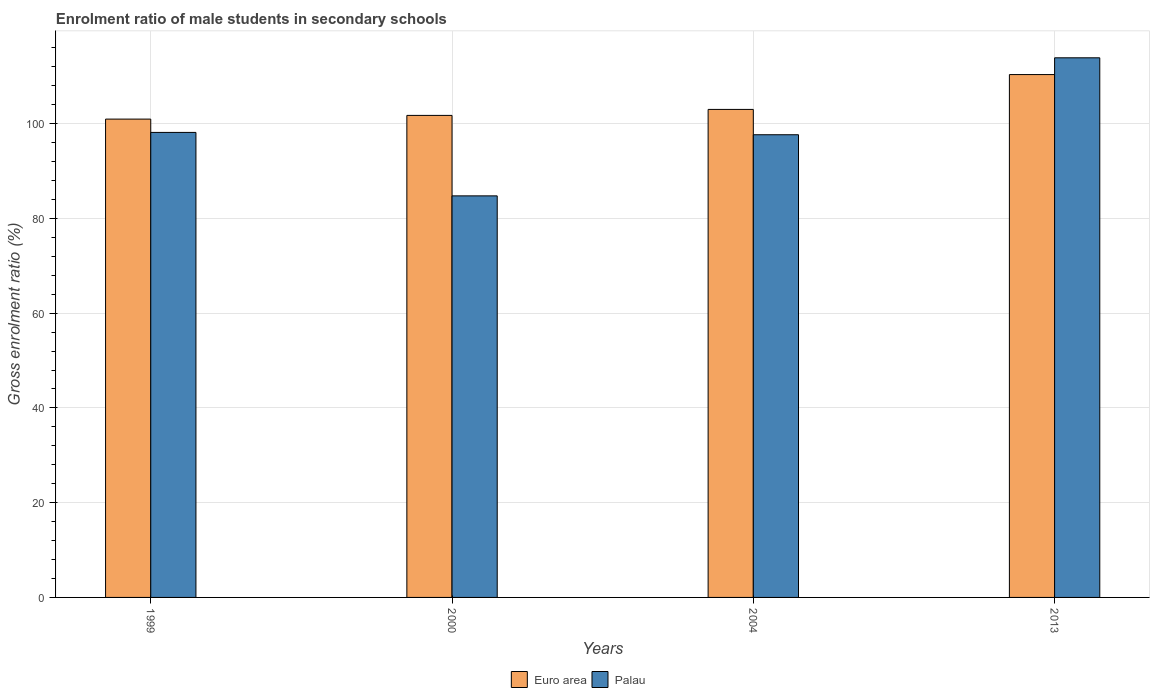How many different coloured bars are there?
Keep it short and to the point. 2. Are the number of bars per tick equal to the number of legend labels?
Give a very brief answer. Yes. Are the number of bars on each tick of the X-axis equal?
Keep it short and to the point. Yes. How many bars are there on the 4th tick from the left?
Give a very brief answer. 2. How many bars are there on the 4th tick from the right?
Give a very brief answer. 2. What is the label of the 2nd group of bars from the left?
Offer a terse response. 2000. In how many cases, is the number of bars for a given year not equal to the number of legend labels?
Ensure brevity in your answer.  0. What is the enrolment ratio of male students in secondary schools in Palau in 2004?
Keep it short and to the point. 97.66. Across all years, what is the maximum enrolment ratio of male students in secondary schools in Euro area?
Make the answer very short. 110.36. Across all years, what is the minimum enrolment ratio of male students in secondary schools in Euro area?
Offer a very short reply. 100.97. In which year was the enrolment ratio of male students in secondary schools in Palau minimum?
Make the answer very short. 2000. What is the total enrolment ratio of male students in secondary schools in Euro area in the graph?
Make the answer very short. 416.09. What is the difference between the enrolment ratio of male students in secondary schools in Euro area in 2000 and that in 2004?
Offer a terse response. -1.26. What is the difference between the enrolment ratio of male students in secondary schools in Euro area in 2000 and the enrolment ratio of male students in secondary schools in Palau in 2013?
Ensure brevity in your answer.  -12.16. What is the average enrolment ratio of male students in secondary schools in Euro area per year?
Offer a very short reply. 104.02. In the year 2013, what is the difference between the enrolment ratio of male students in secondary schools in Palau and enrolment ratio of male students in secondary schools in Euro area?
Your answer should be compact. 3.54. In how many years, is the enrolment ratio of male students in secondary schools in Palau greater than 60 %?
Keep it short and to the point. 4. What is the ratio of the enrolment ratio of male students in secondary schools in Palau in 1999 to that in 2000?
Offer a very short reply. 1.16. Is the enrolment ratio of male students in secondary schools in Euro area in 1999 less than that in 2004?
Your answer should be very brief. Yes. What is the difference between the highest and the second highest enrolment ratio of male students in secondary schools in Euro area?
Provide a short and direct response. 7.35. What is the difference between the highest and the lowest enrolment ratio of male students in secondary schools in Euro area?
Provide a short and direct response. 9.4. In how many years, is the enrolment ratio of male students in secondary schools in Euro area greater than the average enrolment ratio of male students in secondary schools in Euro area taken over all years?
Your answer should be compact. 1. What does the 1st bar from the left in 1999 represents?
Make the answer very short. Euro area. What does the 2nd bar from the right in 2004 represents?
Provide a succinct answer. Euro area. How many bars are there?
Give a very brief answer. 8. Are all the bars in the graph horizontal?
Your answer should be very brief. No. Are the values on the major ticks of Y-axis written in scientific E-notation?
Offer a terse response. No. Does the graph contain any zero values?
Make the answer very short. No. Where does the legend appear in the graph?
Keep it short and to the point. Bottom center. How many legend labels are there?
Your response must be concise. 2. What is the title of the graph?
Keep it short and to the point. Enrolment ratio of male students in secondary schools. Does "Cote d'Ivoire" appear as one of the legend labels in the graph?
Your answer should be very brief. No. What is the label or title of the X-axis?
Offer a terse response. Years. What is the Gross enrolment ratio (%) of Euro area in 1999?
Provide a succinct answer. 100.97. What is the Gross enrolment ratio (%) in Palau in 1999?
Provide a succinct answer. 98.15. What is the Gross enrolment ratio (%) in Euro area in 2000?
Keep it short and to the point. 101.75. What is the Gross enrolment ratio (%) in Palau in 2000?
Provide a short and direct response. 84.76. What is the Gross enrolment ratio (%) of Euro area in 2004?
Ensure brevity in your answer.  103.01. What is the Gross enrolment ratio (%) in Palau in 2004?
Offer a very short reply. 97.66. What is the Gross enrolment ratio (%) in Euro area in 2013?
Offer a very short reply. 110.36. What is the Gross enrolment ratio (%) in Palau in 2013?
Provide a short and direct response. 113.9. Across all years, what is the maximum Gross enrolment ratio (%) in Euro area?
Offer a very short reply. 110.36. Across all years, what is the maximum Gross enrolment ratio (%) in Palau?
Make the answer very short. 113.9. Across all years, what is the minimum Gross enrolment ratio (%) of Euro area?
Give a very brief answer. 100.97. Across all years, what is the minimum Gross enrolment ratio (%) of Palau?
Give a very brief answer. 84.76. What is the total Gross enrolment ratio (%) of Euro area in the graph?
Give a very brief answer. 416.09. What is the total Gross enrolment ratio (%) in Palau in the graph?
Make the answer very short. 394.48. What is the difference between the Gross enrolment ratio (%) in Euro area in 1999 and that in 2000?
Ensure brevity in your answer.  -0.78. What is the difference between the Gross enrolment ratio (%) in Palau in 1999 and that in 2000?
Give a very brief answer. 13.39. What is the difference between the Gross enrolment ratio (%) in Euro area in 1999 and that in 2004?
Offer a terse response. -2.04. What is the difference between the Gross enrolment ratio (%) in Palau in 1999 and that in 2004?
Ensure brevity in your answer.  0.49. What is the difference between the Gross enrolment ratio (%) of Euro area in 1999 and that in 2013?
Your response must be concise. -9.4. What is the difference between the Gross enrolment ratio (%) of Palau in 1999 and that in 2013?
Keep it short and to the point. -15.75. What is the difference between the Gross enrolment ratio (%) of Euro area in 2000 and that in 2004?
Offer a very short reply. -1.26. What is the difference between the Gross enrolment ratio (%) in Palau in 2000 and that in 2004?
Your answer should be very brief. -12.9. What is the difference between the Gross enrolment ratio (%) in Euro area in 2000 and that in 2013?
Your response must be concise. -8.62. What is the difference between the Gross enrolment ratio (%) in Palau in 2000 and that in 2013?
Make the answer very short. -29.14. What is the difference between the Gross enrolment ratio (%) of Euro area in 2004 and that in 2013?
Make the answer very short. -7.35. What is the difference between the Gross enrolment ratio (%) in Palau in 2004 and that in 2013?
Provide a succinct answer. -16.24. What is the difference between the Gross enrolment ratio (%) in Euro area in 1999 and the Gross enrolment ratio (%) in Palau in 2000?
Give a very brief answer. 16.21. What is the difference between the Gross enrolment ratio (%) of Euro area in 1999 and the Gross enrolment ratio (%) of Palau in 2004?
Give a very brief answer. 3.3. What is the difference between the Gross enrolment ratio (%) of Euro area in 1999 and the Gross enrolment ratio (%) of Palau in 2013?
Give a very brief answer. -12.94. What is the difference between the Gross enrolment ratio (%) in Euro area in 2000 and the Gross enrolment ratio (%) in Palau in 2004?
Offer a terse response. 4.08. What is the difference between the Gross enrolment ratio (%) in Euro area in 2000 and the Gross enrolment ratio (%) in Palau in 2013?
Provide a succinct answer. -12.16. What is the difference between the Gross enrolment ratio (%) of Euro area in 2004 and the Gross enrolment ratio (%) of Palau in 2013?
Give a very brief answer. -10.89. What is the average Gross enrolment ratio (%) in Euro area per year?
Your answer should be compact. 104.02. What is the average Gross enrolment ratio (%) of Palau per year?
Your answer should be compact. 98.62. In the year 1999, what is the difference between the Gross enrolment ratio (%) of Euro area and Gross enrolment ratio (%) of Palau?
Keep it short and to the point. 2.81. In the year 2000, what is the difference between the Gross enrolment ratio (%) of Euro area and Gross enrolment ratio (%) of Palau?
Provide a short and direct response. 16.99. In the year 2004, what is the difference between the Gross enrolment ratio (%) in Euro area and Gross enrolment ratio (%) in Palau?
Keep it short and to the point. 5.35. In the year 2013, what is the difference between the Gross enrolment ratio (%) in Euro area and Gross enrolment ratio (%) in Palau?
Make the answer very short. -3.54. What is the ratio of the Gross enrolment ratio (%) of Euro area in 1999 to that in 2000?
Keep it short and to the point. 0.99. What is the ratio of the Gross enrolment ratio (%) in Palau in 1999 to that in 2000?
Your answer should be compact. 1.16. What is the ratio of the Gross enrolment ratio (%) of Euro area in 1999 to that in 2004?
Your answer should be compact. 0.98. What is the ratio of the Gross enrolment ratio (%) in Euro area in 1999 to that in 2013?
Give a very brief answer. 0.91. What is the ratio of the Gross enrolment ratio (%) in Palau in 1999 to that in 2013?
Give a very brief answer. 0.86. What is the ratio of the Gross enrolment ratio (%) in Euro area in 2000 to that in 2004?
Your answer should be very brief. 0.99. What is the ratio of the Gross enrolment ratio (%) in Palau in 2000 to that in 2004?
Provide a succinct answer. 0.87. What is the ratio of the Gross enrolment ratio (%) of Euro area in 2000 to that in 2013?
Provide a succinct answer. 0.92. What is the ratio of the Gross enrolment ratio (%) in Palau in 2000 to that in 2013?
Keep it short and to the point. 0.74. What is the ratio of the Gross enrolment ratio (%) in Euro area in 2004 to that in 2013?
Offer a very short reply. 0.93. What is the ratio of the Gross enrolment ratio (%) of Palau in 2004 to that in 2013?
Provide a short and direct response. 0.86. What is the difference between the highest and the second highest Gross enrolment ratio (%) in Euro area?
Ensure brevity in your answer.  7.35. What is the difference between the highest and the second highest Gross enrolment ratio (%) of Palau?
Offer a very short reply. 15.75. What is the difference between the highest and the lowest Gross enrolment ratio (%) in Euro area?
Keep it short and to the point. 9.4. What is the difference between the highest and the lowest Gross enrolment ratio (%) in Palau?
Offer a terse response. 29.14. 